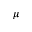<formula> <loc_0><loc_0><loc_500><loc_500>\mu</formula> 